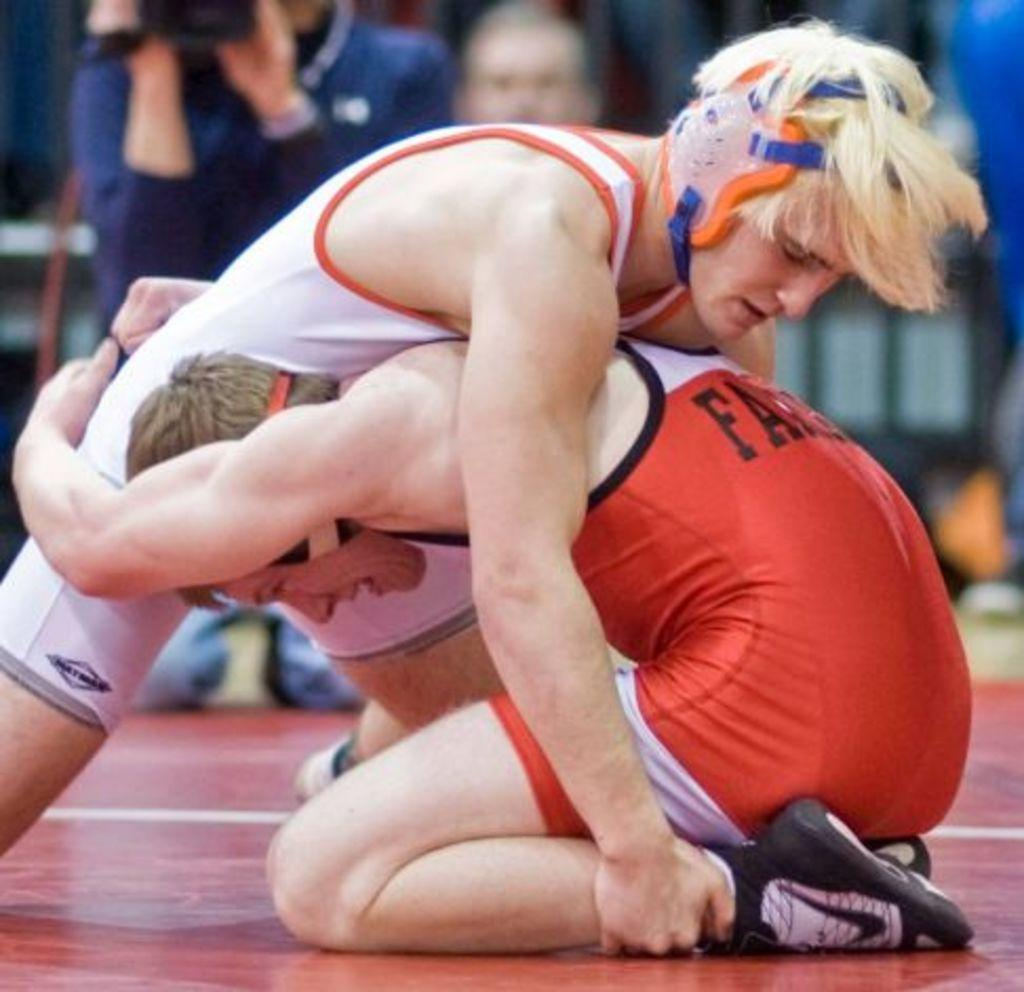<image>
Describe the image concisely. The man in red has the word starting with FA on the back of his top. 